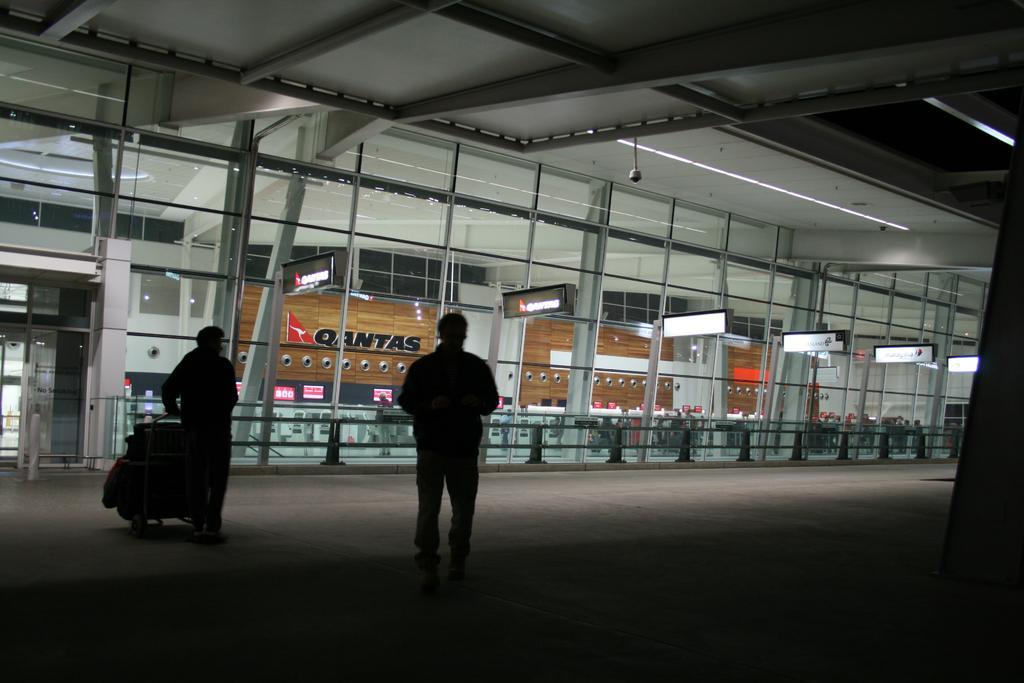Can you describe this image briefly? In this image there are two people walking with a luggage trolley in front of the airport, at the top of the image there are a few CCTV cameras, in the background of the image there is the counter of an airplane service provider. 